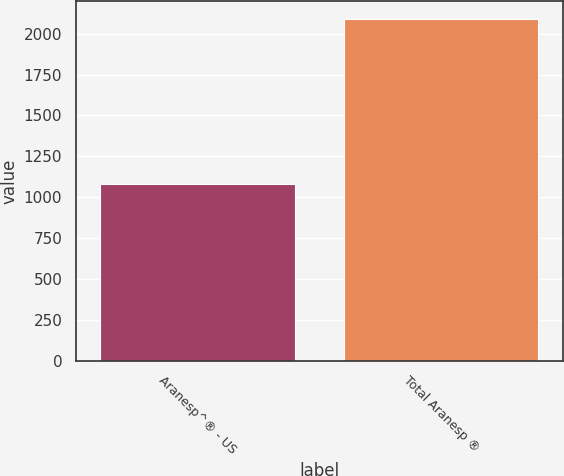Convert chart to OTSL. <chart><loc_0><loc_0><loc_500><loc_500><bar_chart><fcel>Aranesp^® - US<fcel>Total Aranesp ®<nl><fcel>1082<fcel>2093<nl></chart> 